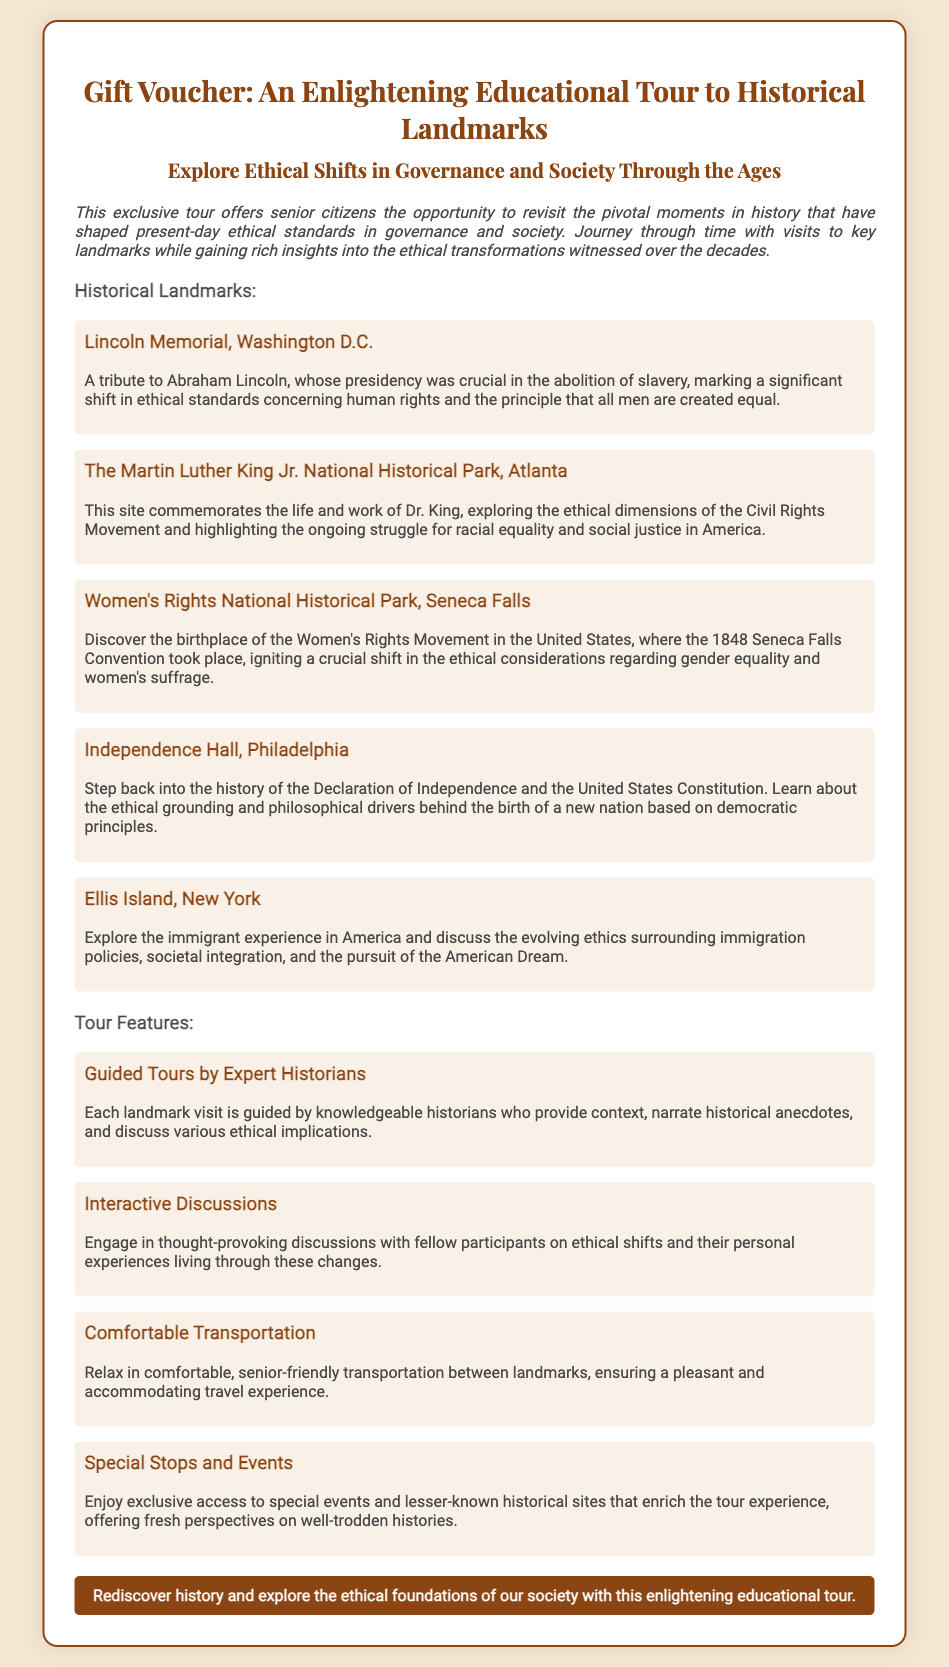What is the title of the voucher? The title of the voucher is presented prominently at the top of the document, which is "Gift Voucher: An Enlightening Educational Tour to Historical Landmarks."
Answer: Gift Voucher: An Enlightening Educational Tour to Historical Landmarks How many historical landmarks are listed? The document contains a section titled "Historical Landmarks," where five landmarks are detailed.
Answer: Five What landmark commemorates Abraham Lincoln? The specific landmark that commemorates Abraham Lincoln is mentioned directly under the historical landmarks section.
Answer: Lincoln Memorial What is one of the ethical themes explored at Independence Hall? The document states that Independence Hall relates to the ethical grounding behind the United States Constitution, which is a key theme.
Answer: Democratic principles Who provides guided tours? The document notes that knowledgeable historians are responsible for guiding the tours at each landmark, emphasizing their role.
Answer: Expert historians What type of discussions are included in the tour? The tour includes a feature that encourages engaging and thought-provoking discussions among participants regarding ethical shifts.
Answer: Interactive discussions What is one special aspect of transportation mentioned? The document describes the transportation as "comfortable, senior-friendly," indicating its focus on catering to senior citizens' needs.
Answer: Senior-friendly transportation Which historical event is associated with the Women's Rights National Historical Park? The document highlights the Seneca Falls Convention as the significant historical event connected to the Women's Rights National Historical Park.
Answer: Seneca Falls Convention 